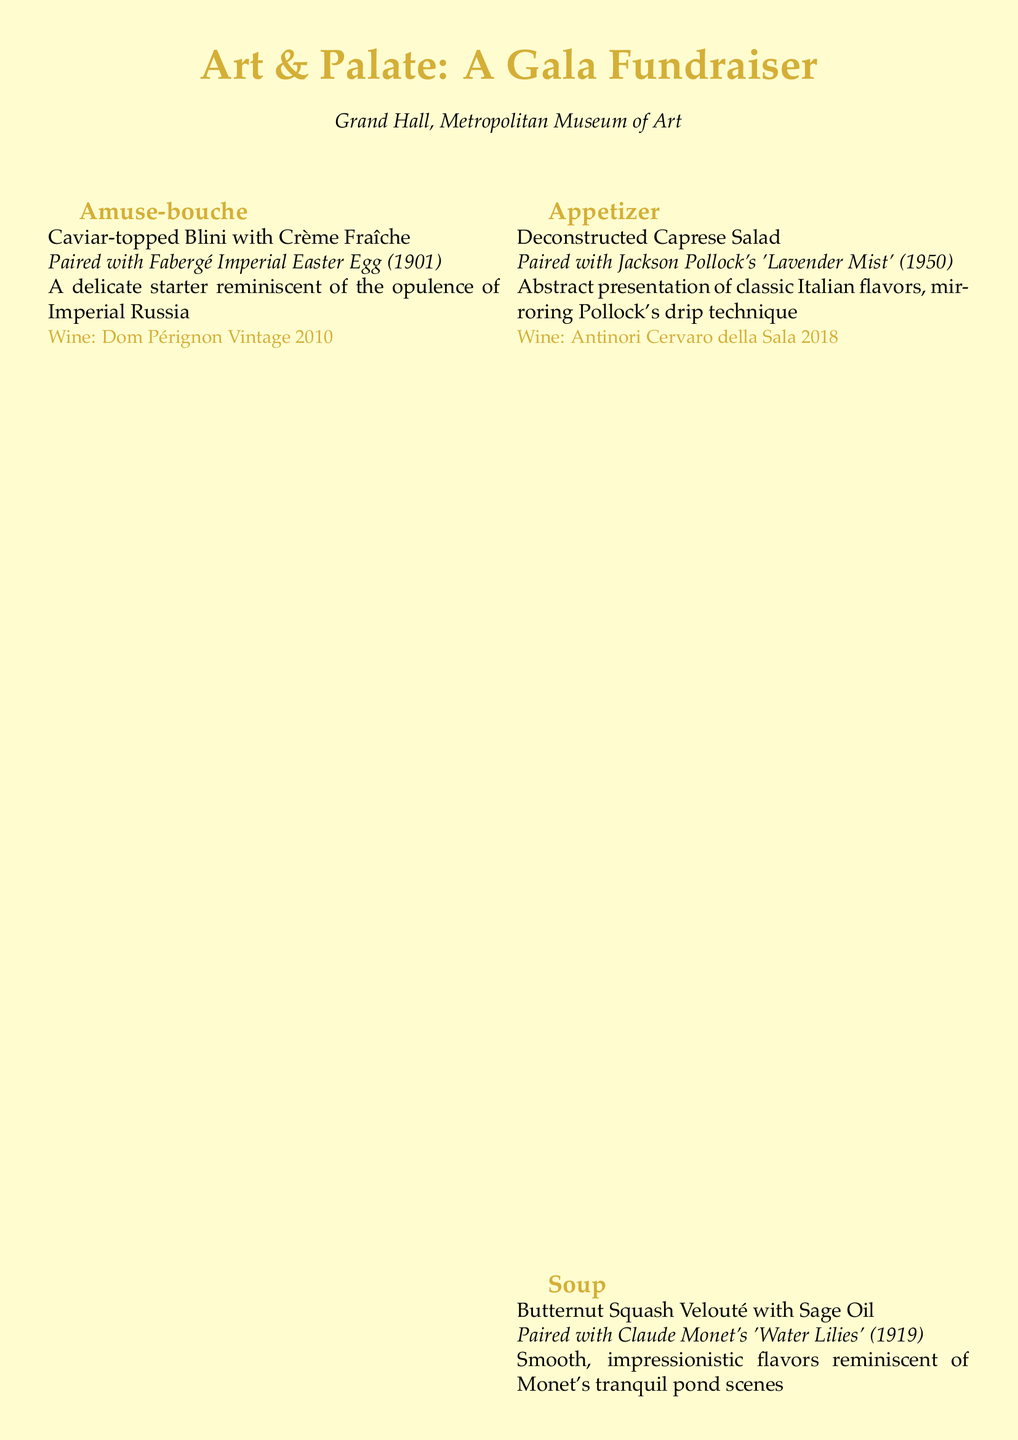What is the title of the event? The title of the event is mentioned at the beginning of the document, which is "Art & Palate: A Gala Fundraiser."
Answer: Art & Palate: A Gala Fundraiser Where is the event held? The document specifies the location of the event in the introduction, which is "Grand Hall, Metropolitan Museum of Art."
Answer: Grand Hall, Metropolitan Museum of Art What is served as the amuse-bouche? The amuse-bouche course includes caviar-topped blini with crème fraîche, as listed in the menu.
Answer: Caviar-topped Blini with Crème Fraîche What artwork is paired with the dessert? The dessert is paired with Gustav Klimt's "The Kiss," which is noted in that section of the menu.
Answer: Gustav Klimt's 'The Kiss' (1908) Which wine is paired with the appetizer? The specific wine mentioned alongside the appetizer course is "Antinori Cervaro della Sala 2018."
Answer: Antinori Cervaro della Sala 2018 How many courses are listed in the menu? The document includes five distinct courses: amuse-bouche, appetizer, soup, main course, and dessert.
Answer: Five What type of options are available upon request? The menu mentions that vegetarian and vegan options can be requested, highlighting inclusivity.
Answer: Vegetarian and vegan options Which artwork is associated with the soup course? The soup course is paired with Claude Monet's "Water Lilies," as stated in the menu description.
Answer: Claude Monet's 'Water Lilies' (1919) What is a key note mentioned about the ingredients? The document highlights that all ingredients are sourced from local, sustainable producers, emphasized in the special notes.
Answer: Local, sustainable producers 